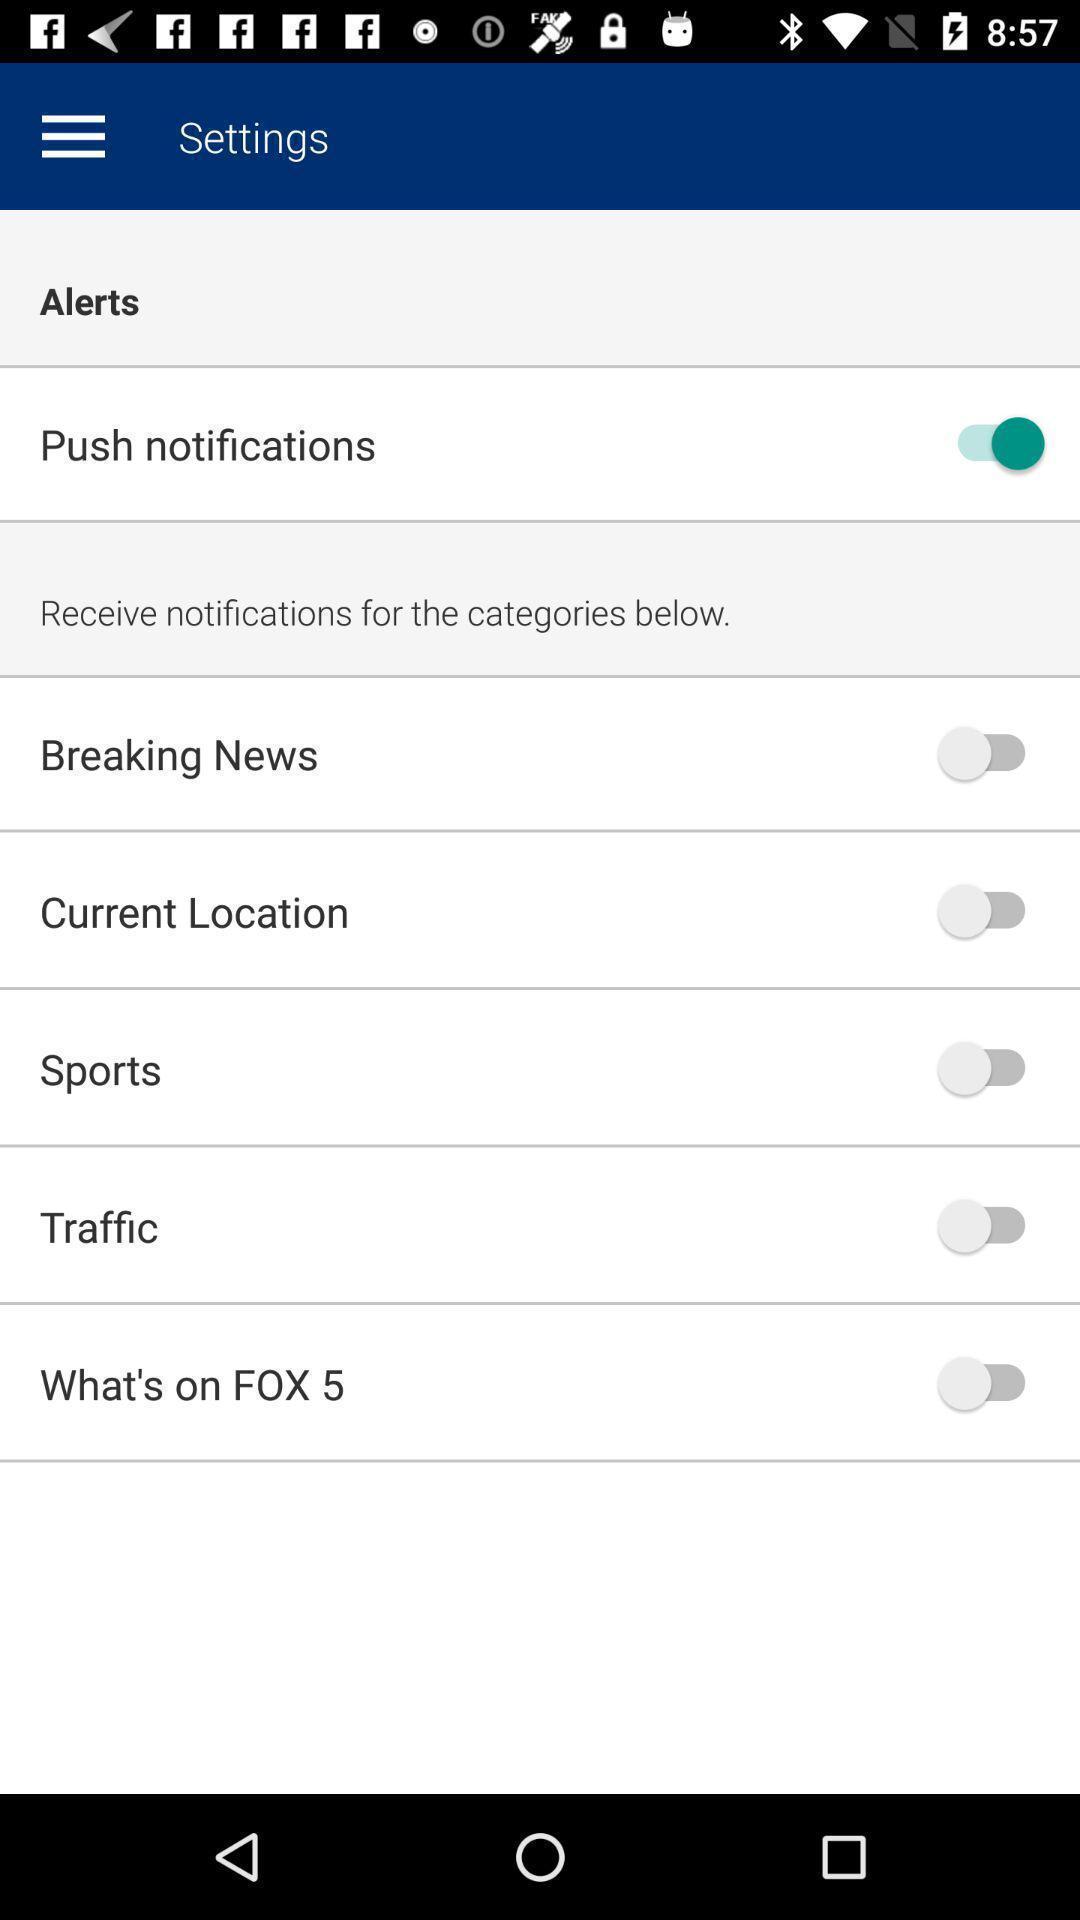Give me a summary of this screen capture. Settings page of a news application. 